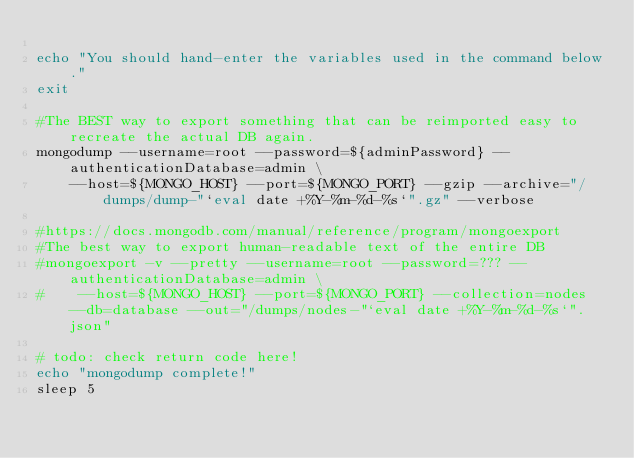<code> <loc_0><loc_0><loc_500><loc_500><_Bash_>
echo "You should hand-enter the variables used in the command below."
exit

#The BEST way to export something that can be reimported easy to recreate the actual DB again.
mongodump --username=root --password=${adminPassword} --authenticationDatabase=admin \
    --host=${MONGO_HOST} --port=${MONGO_PORT} --gzip --archive="/dumps/dump-"`eval date +%Y-%m-%d-%s`".gz" --verbose

#https://docs.mongodb.com/manual/reference/program/mongoexport
#The best way to export human-readable text of the entire DB
#mongoexport -v --pretty --username=root --password=??? --authenticationDatabase=admin \
#    --host=${MONGO_HOST} --port=${MONGO_PORT} --collection=nodes --db=database --out="/dumps/nodes-"`eval date +%Y-%m-%d-%s`".json"

# todo: check return code here!
echo "mongodump complete!"
sleep 5
</code> 